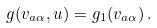Convert formula to latex. <formula><loc_0><loc_0><loc_500><loc_500>g ( v _ { a \alpha } , u ) = g _ { 1 } ( v _ { a \alpha } ) \, .</formula> 